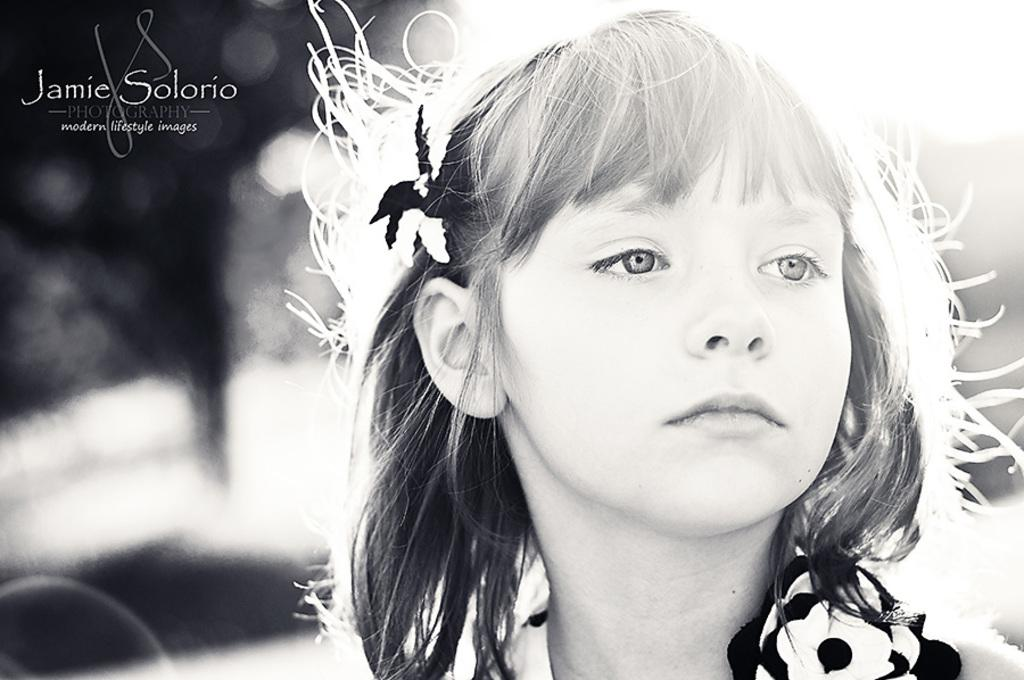Who is present in the image? There is a woman in the image. What can be seen in the top left corner of the image? There is a watermark in the top left corner of the image. What color scheme is used in the image? The image is black and white in color. What type of medical advice is the woman giving at the seashore in the image? There is no seashore present in the image, and the woman is not depicted as giving any medical advice. 